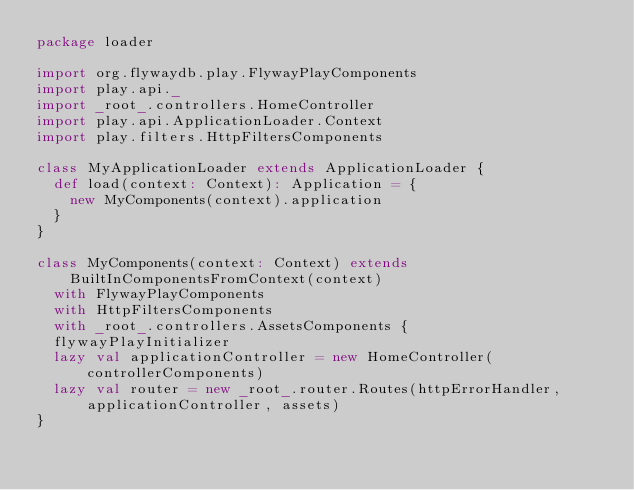Convert code to text. <code><loc_0><loc_0><loc_500><loc_500><_Scala_>package loader

import org.flywaydb.play.FlywayPlayComponents
import play.api._
import _root_.controllers.HomeController
import play.api.ApplicationLoader.Context
import play.filters.HttpFiltersComponents

class MyApplicationLoader extends ApplicationLoader {
  def load(context: Context): Application = {
    new MyComponents(context).application
  }
}

class MyComponents(context: Context) extends BuiltInComponentsFromContext(context)
  with FlywayPlayComponents
  with HttpFiltersComponents
  with _root_.controllers.AssetsComponents {
  flywayPlayInitializer
  lazy val applicationController = new HomeController(controllerComponents)
  lazy val router = new _root_.router.Routes(httpErrorHandler, applicationController, assets)
}</code> 